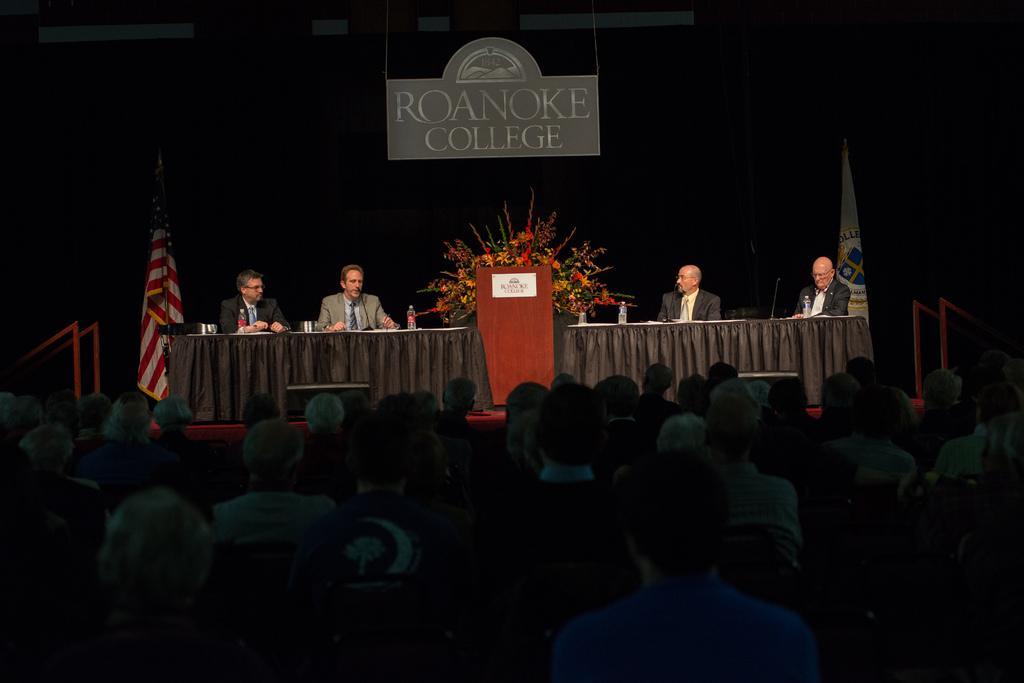Can you describe this image briefly? In this picture we can see a group of people sitting on chairs and in front of them on stage we can see a table, bottles, mics, flags, name boards, rods, flowers and four men wore blazers, ties and in the background it is dark. 